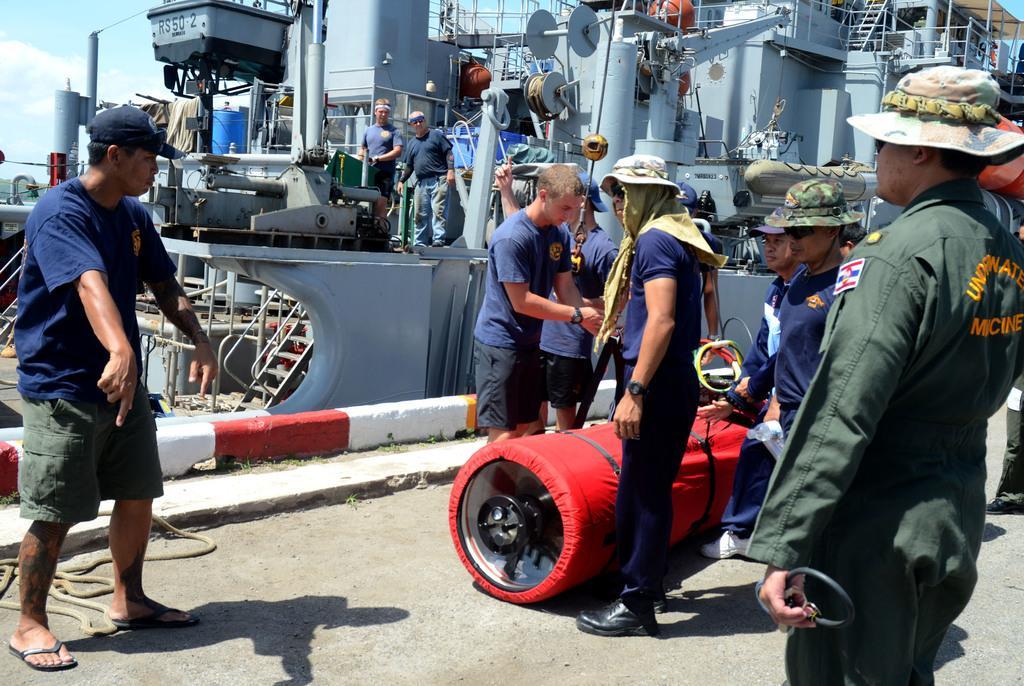Can you describe this image briefly? In this image there are a group of people who are standing, and in the foreground there are a group of people who are carrying some object. In the background there are some machines, ships, ropes and some other objects. At the bottom there is a floor, on the floor there is a pipe and at the top of the image there is sky. 